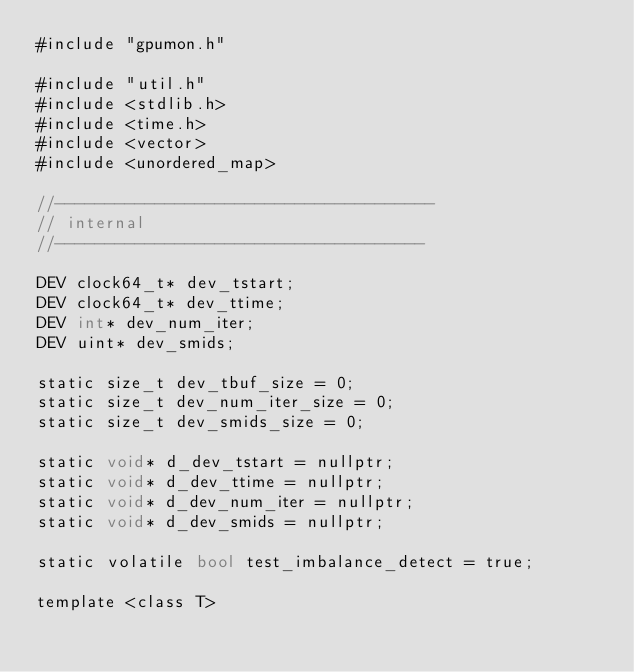<code> <loc_0><loc_0><loc_500><loc_500><_Cuda_>#include "gpumon.h"

#include "util.h"
#include <stdlib.h>
#include <time.h>
#include <vector>
#include <unordered_map>

//--------------------------------------
// internal
//-------------------------------------

DEV clock64_t* dev_tstart;
DEV clock64_t* dev_ttime;
DEV int* dev_num_iter;
DEV uint* dev_smids;

static size_t dev_tbuf_size = 0;
static size_t dev_num_iter_size = 0;
static size_t dev_smids_size = 0;

static void* d_dev_tstart = nullptr;
static void* d_dev_ttime = nullptr;
static void* d_dev_num_iter = nullptr;
static void* d_dev_smids = nullptr;

static volatile bool test_imbalance_detect = true;

template <class T></code> 